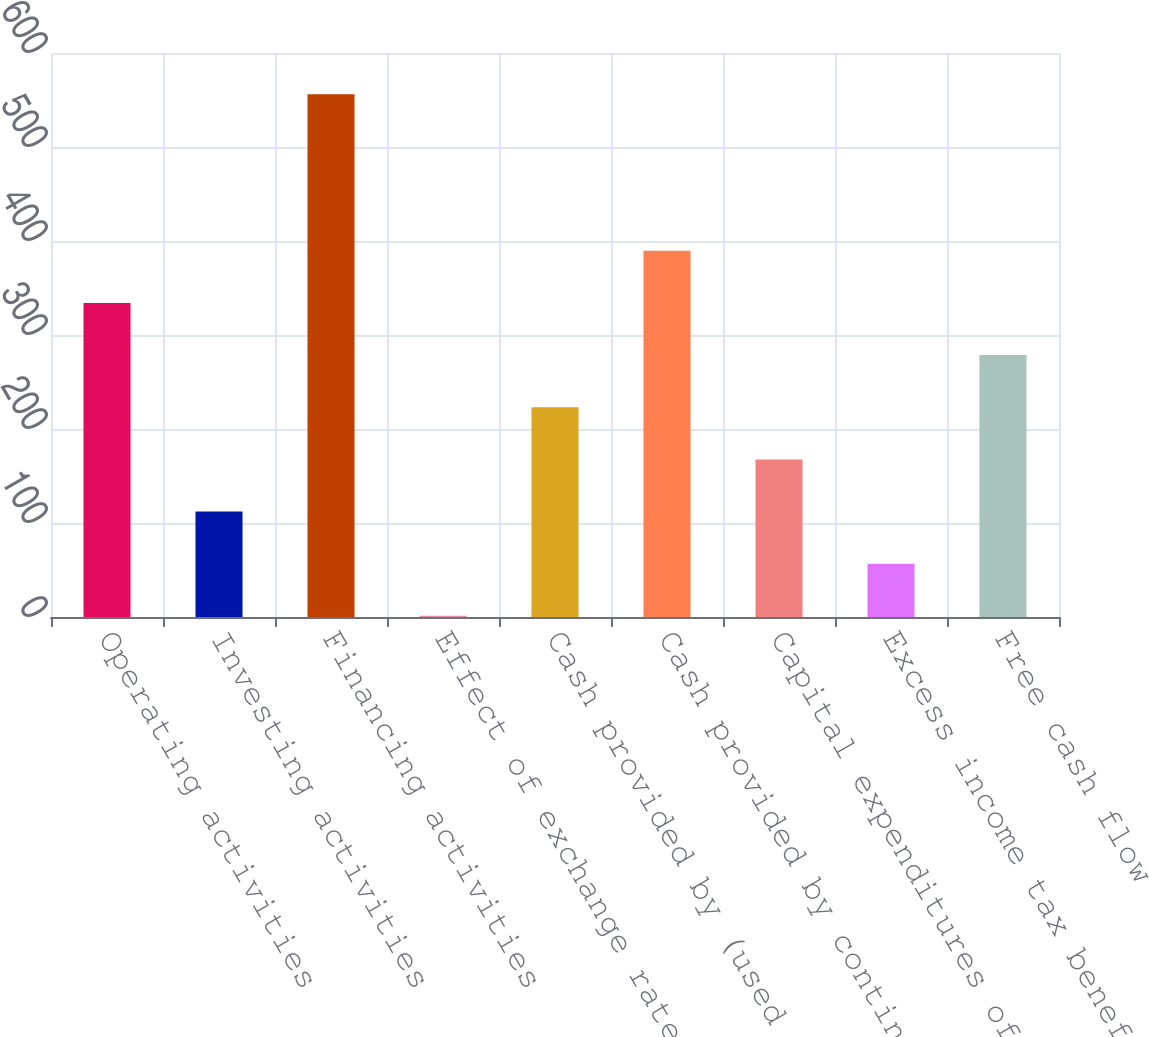Convert chart. <chart><loc_0><loc_0><loc_500><loc_500><bar_chart><fcel>Operating activities<fcel>Investing activities<fcel>Financing activities<fcel>Effect of exchange rate<fcel>Cash provided by (used for)<fcel>Cash provided by continuing<fcel>Capital expenditures of<fcel>Excess income tax benefit from<fcel>Free cash flow<nl><fcel>334.14<fcel>112.18<fcel>556.1<fcel>1.2<fcel>223.16<fcel>389.63<fcel>167.67<fcel>56.69<fcel>278.65<nl></chart> 